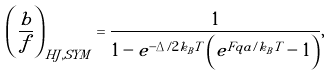Convert formula to latex. <formula><loc_0><loc_0><loc_500><loc_500>\left ( \frac { b } { f } \right ) _ { H J , S Y M } = \frac { 1 } { 1 - e ^ { - \Delta / 2 k _ { B } T } \left ( e ^ { F q a / k _ { B } T } - 1 \right ) } ,</formula> 